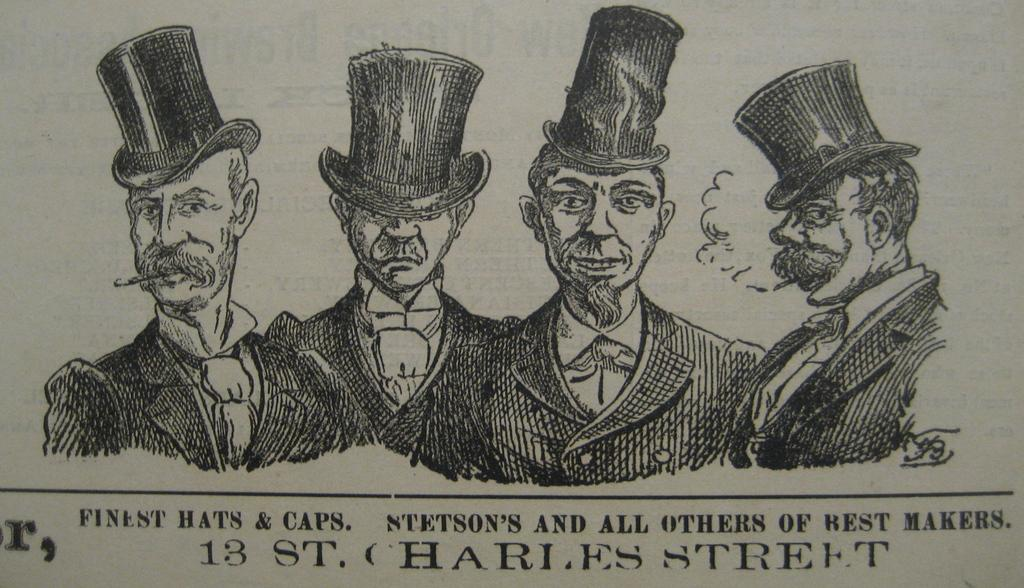What is present in the image that contains visual information? There is a paper in the image. What type of content is depicted on the paper? The paper contains pictures of people. Is there any written information on the paper? Yes, there is text on the paper. What type of cork can be seen on the paper in the image? There is no cork present on the paper in the image. What type of leaf is depicted in the pictures of people on the paper? The pictures of people on the paper do not depict any leaves. 